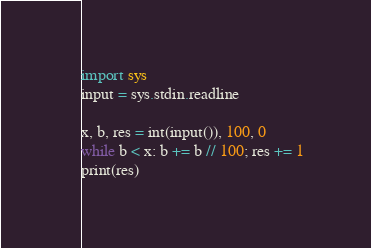<code> <loc_0><loc_0><loc_500><loc_500><_Python_>import sys
input = sys.stdin.readline

x, b, res = int(input()), 100, 0
while b < x: b += b // 100; res += 1
print(res)</code> 